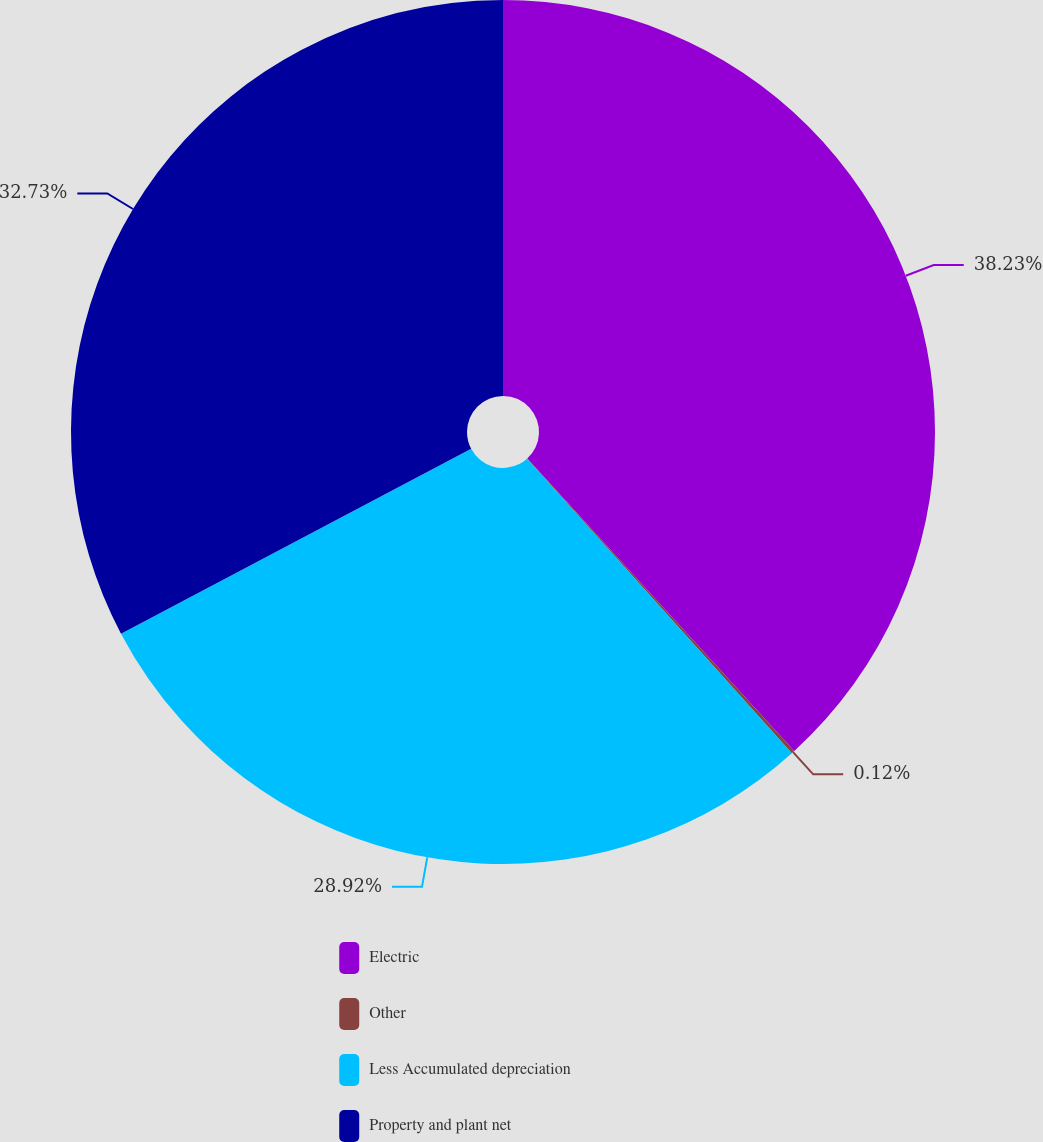Convert chart to OTSL. <chart><loc_0><loc_0><loc_500><loc_500><pie_chart><fcel>Electric<fcel>Other<fcel>Less Accumulated depreciation<fcel>Property and plant net<nl><fcel>38.22%<fcel>0.12%<fcel>28.92%<fcel>32.73%<nl></chart> 